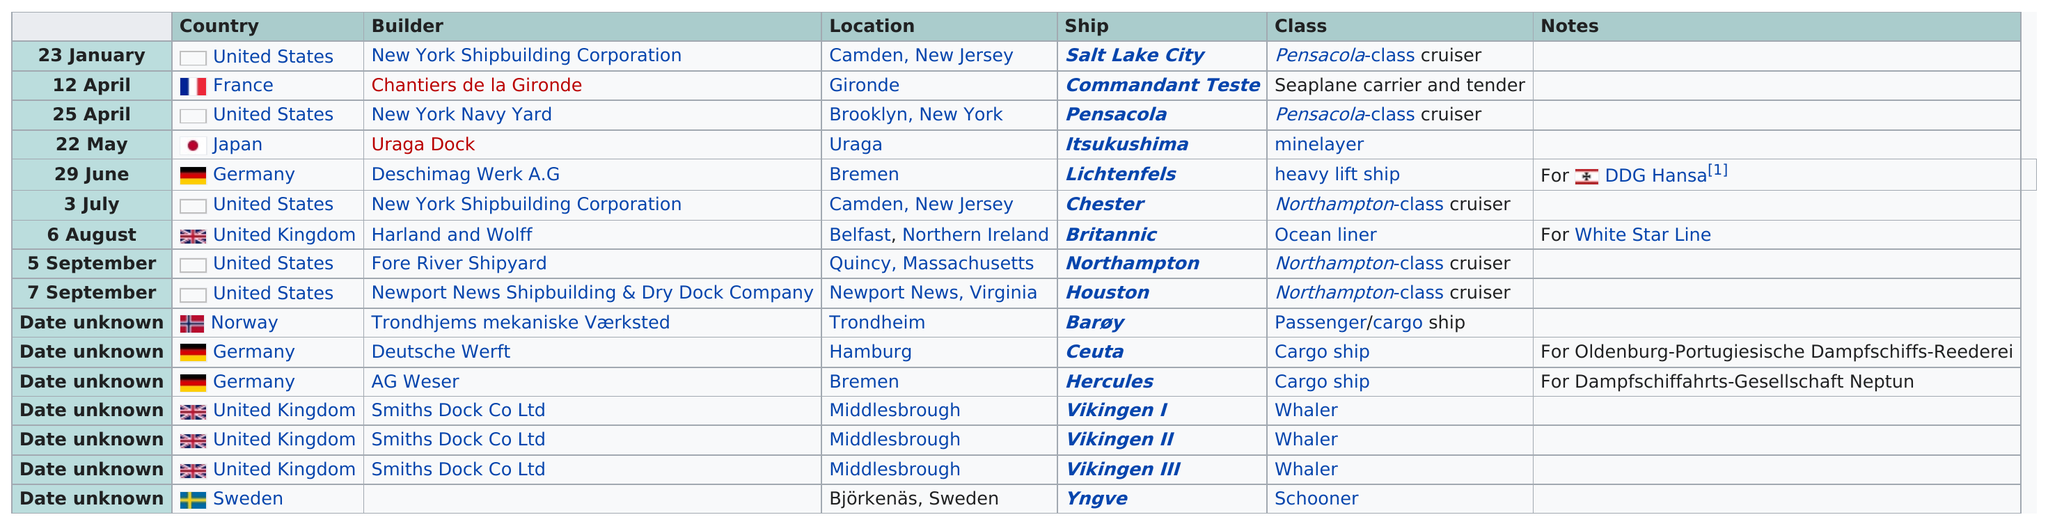Highlight a few significant elements in this photo. After the launch of the salt lake city, the next ship to be launched was Commandant Teste. In the year 1929, the average number of ship launches was 16. For each ship, I will list the information of which were built by the New York Navy Yard, specifically the Pensacola. The United States built the most ships according to the cart. The name of the last ship on the chart is Yngve. 